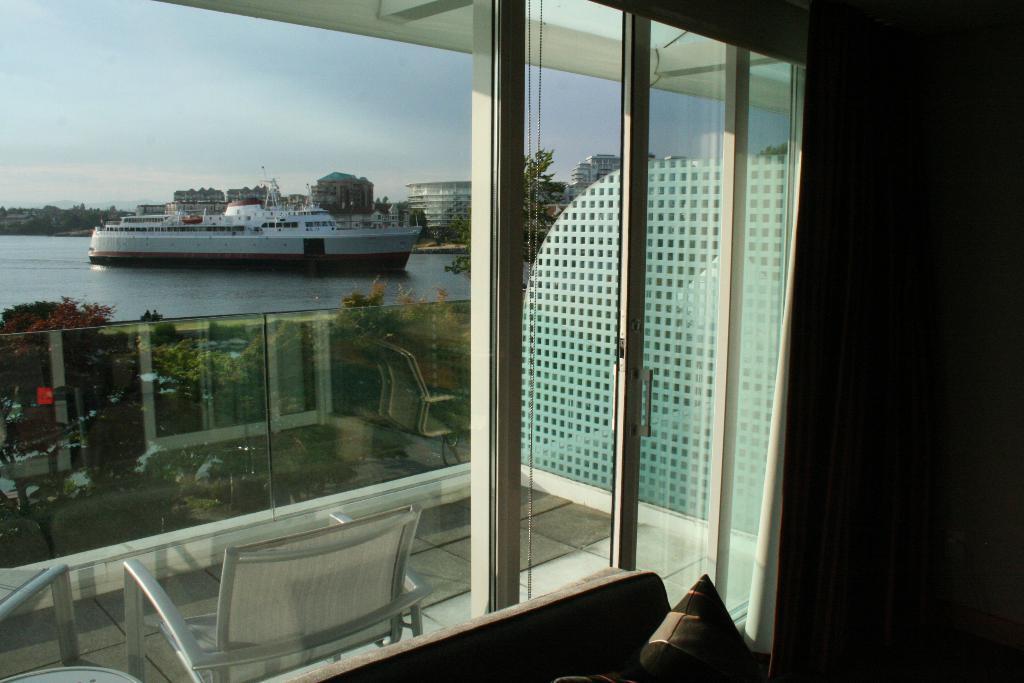Describe this image in one or two sentences. In this image we can see the sofa with pillows, glass doors through which we can see the chair, plants, ship floating on water, buildings and the sky in the background. 